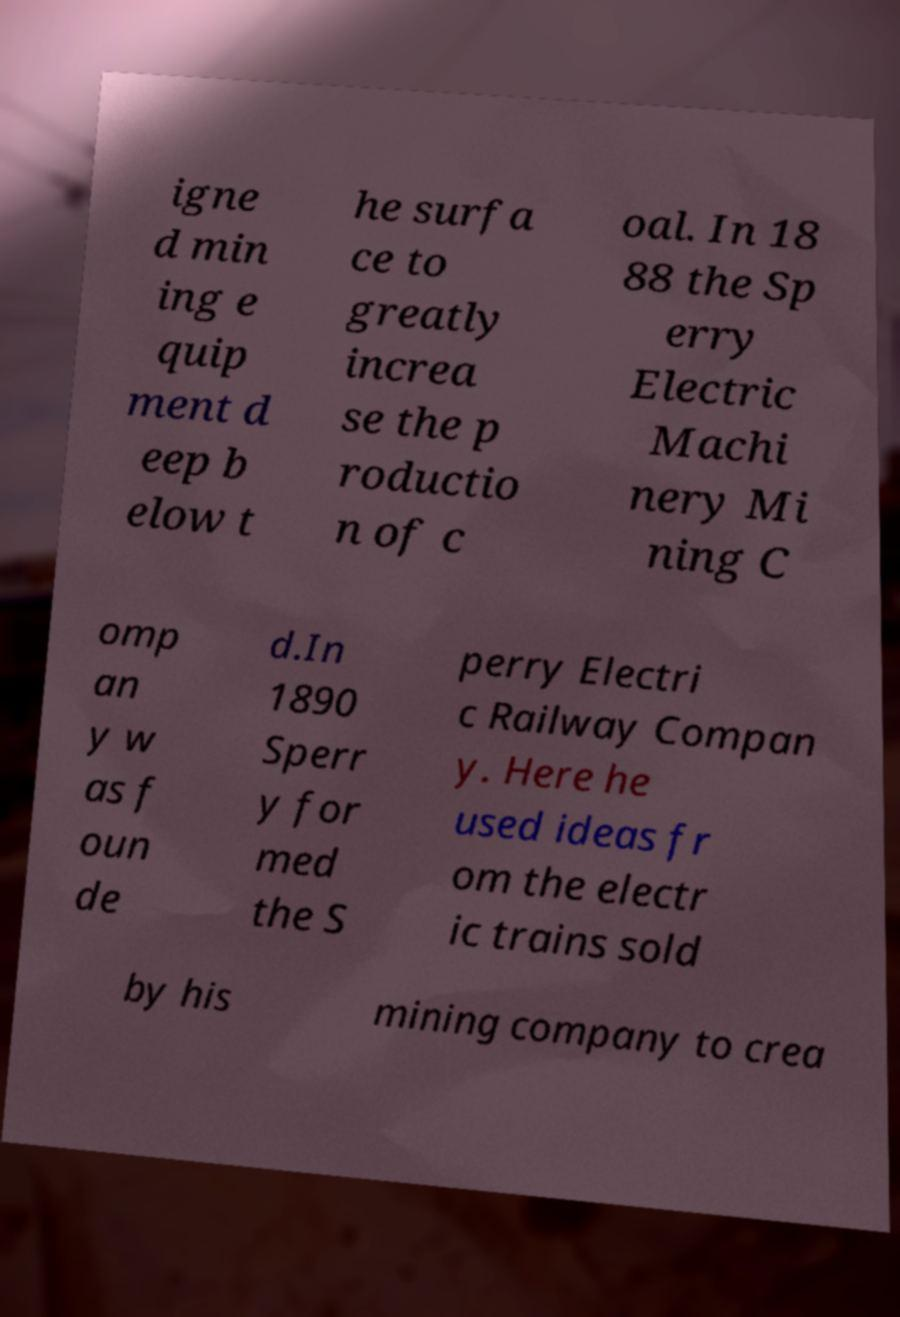There's text embedded in this image that I need extracted. Can you transcribe it verbatim? igne d min ing e quip ment d eep b elow t he surfa ce to greatly increa se the p roductio n of c oal. In 18 88 the Sp erry Electric Machi nery Mi ning C omp an y w as f oun de d.In 1890 Sperr y for med the S perry Electri c Railway Compan y. Here he used ideas fr om the electr ic trains sold by his mining company to crea 